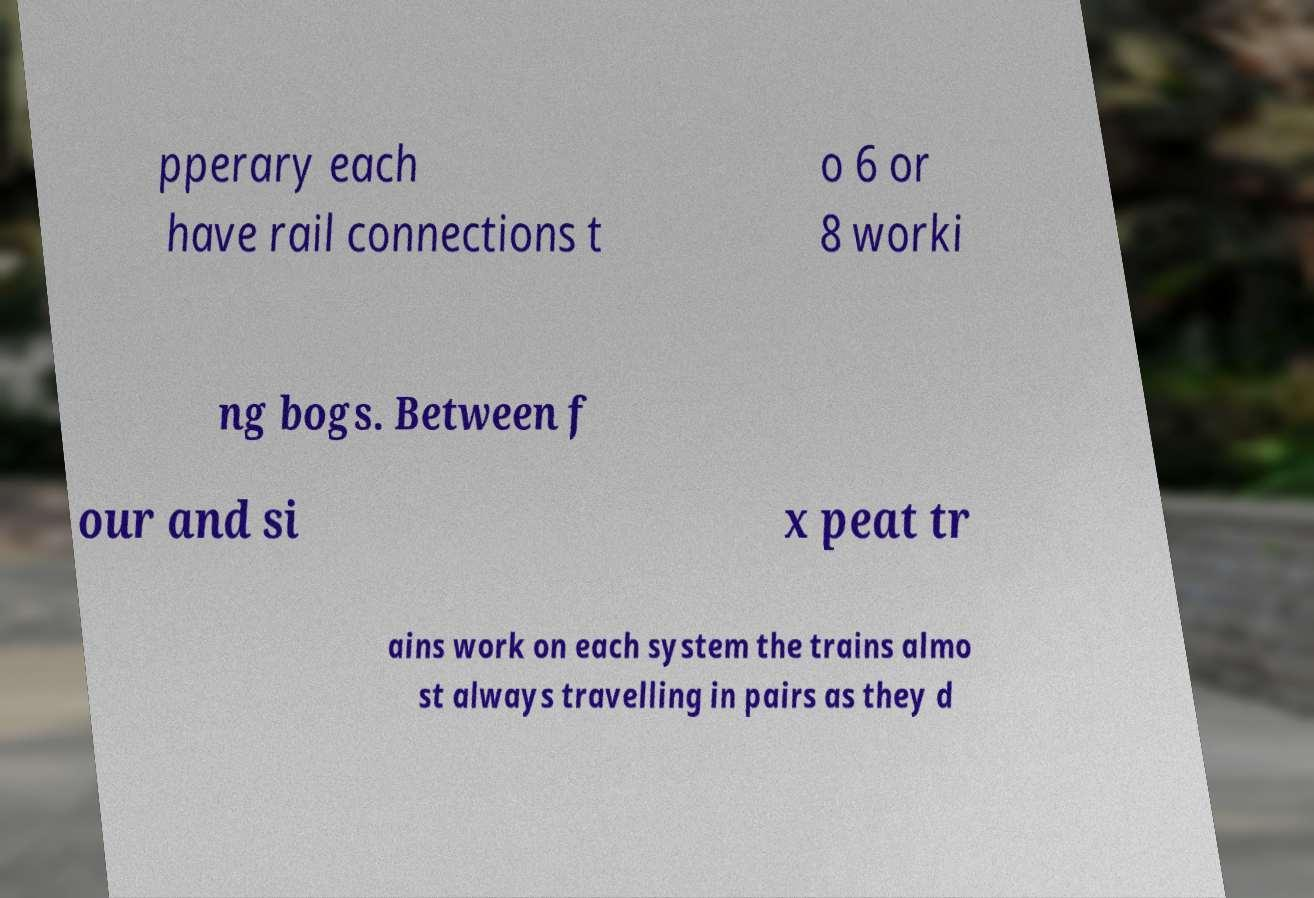There's text embedded in this image that I need extracted. Can you transcribe it verbatim? pperary each have rail connections t o 6 or 8 worki ng bogs. Between f our and si x peat tr ains work on each system the trains almo st always travelling in pairs as they d 